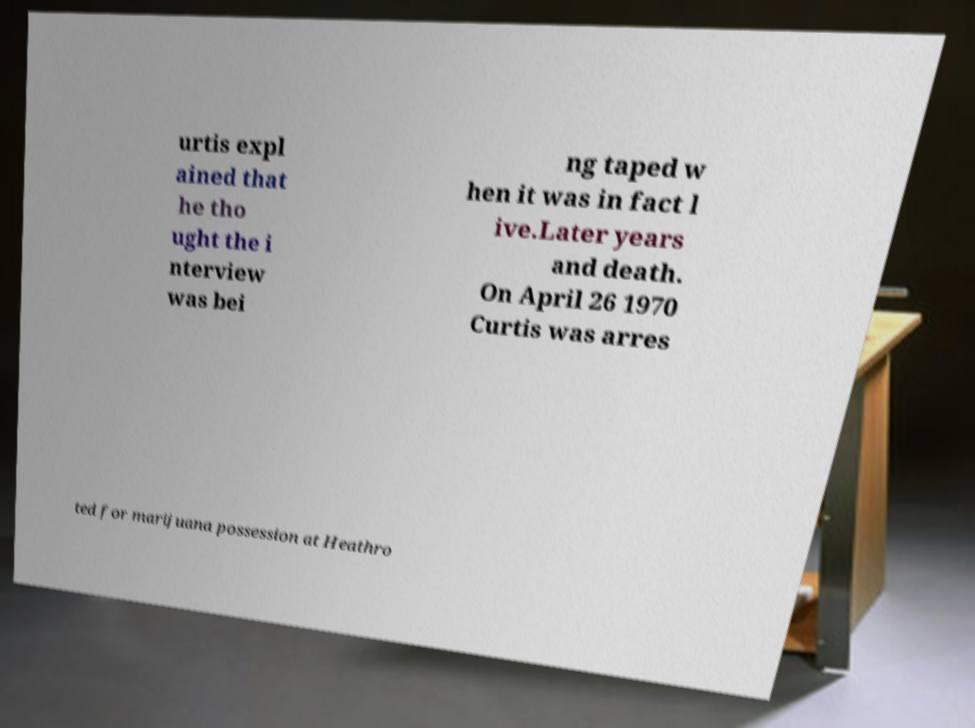Please read and relay the text visible in this image. What does it say? urtis expl ained that he tho ught the i nterview was bei ng taped w hen it was in fact l ive.Later years and death. On April 26 1970 Curtis was arres ted for marijuana possession at Heathro 